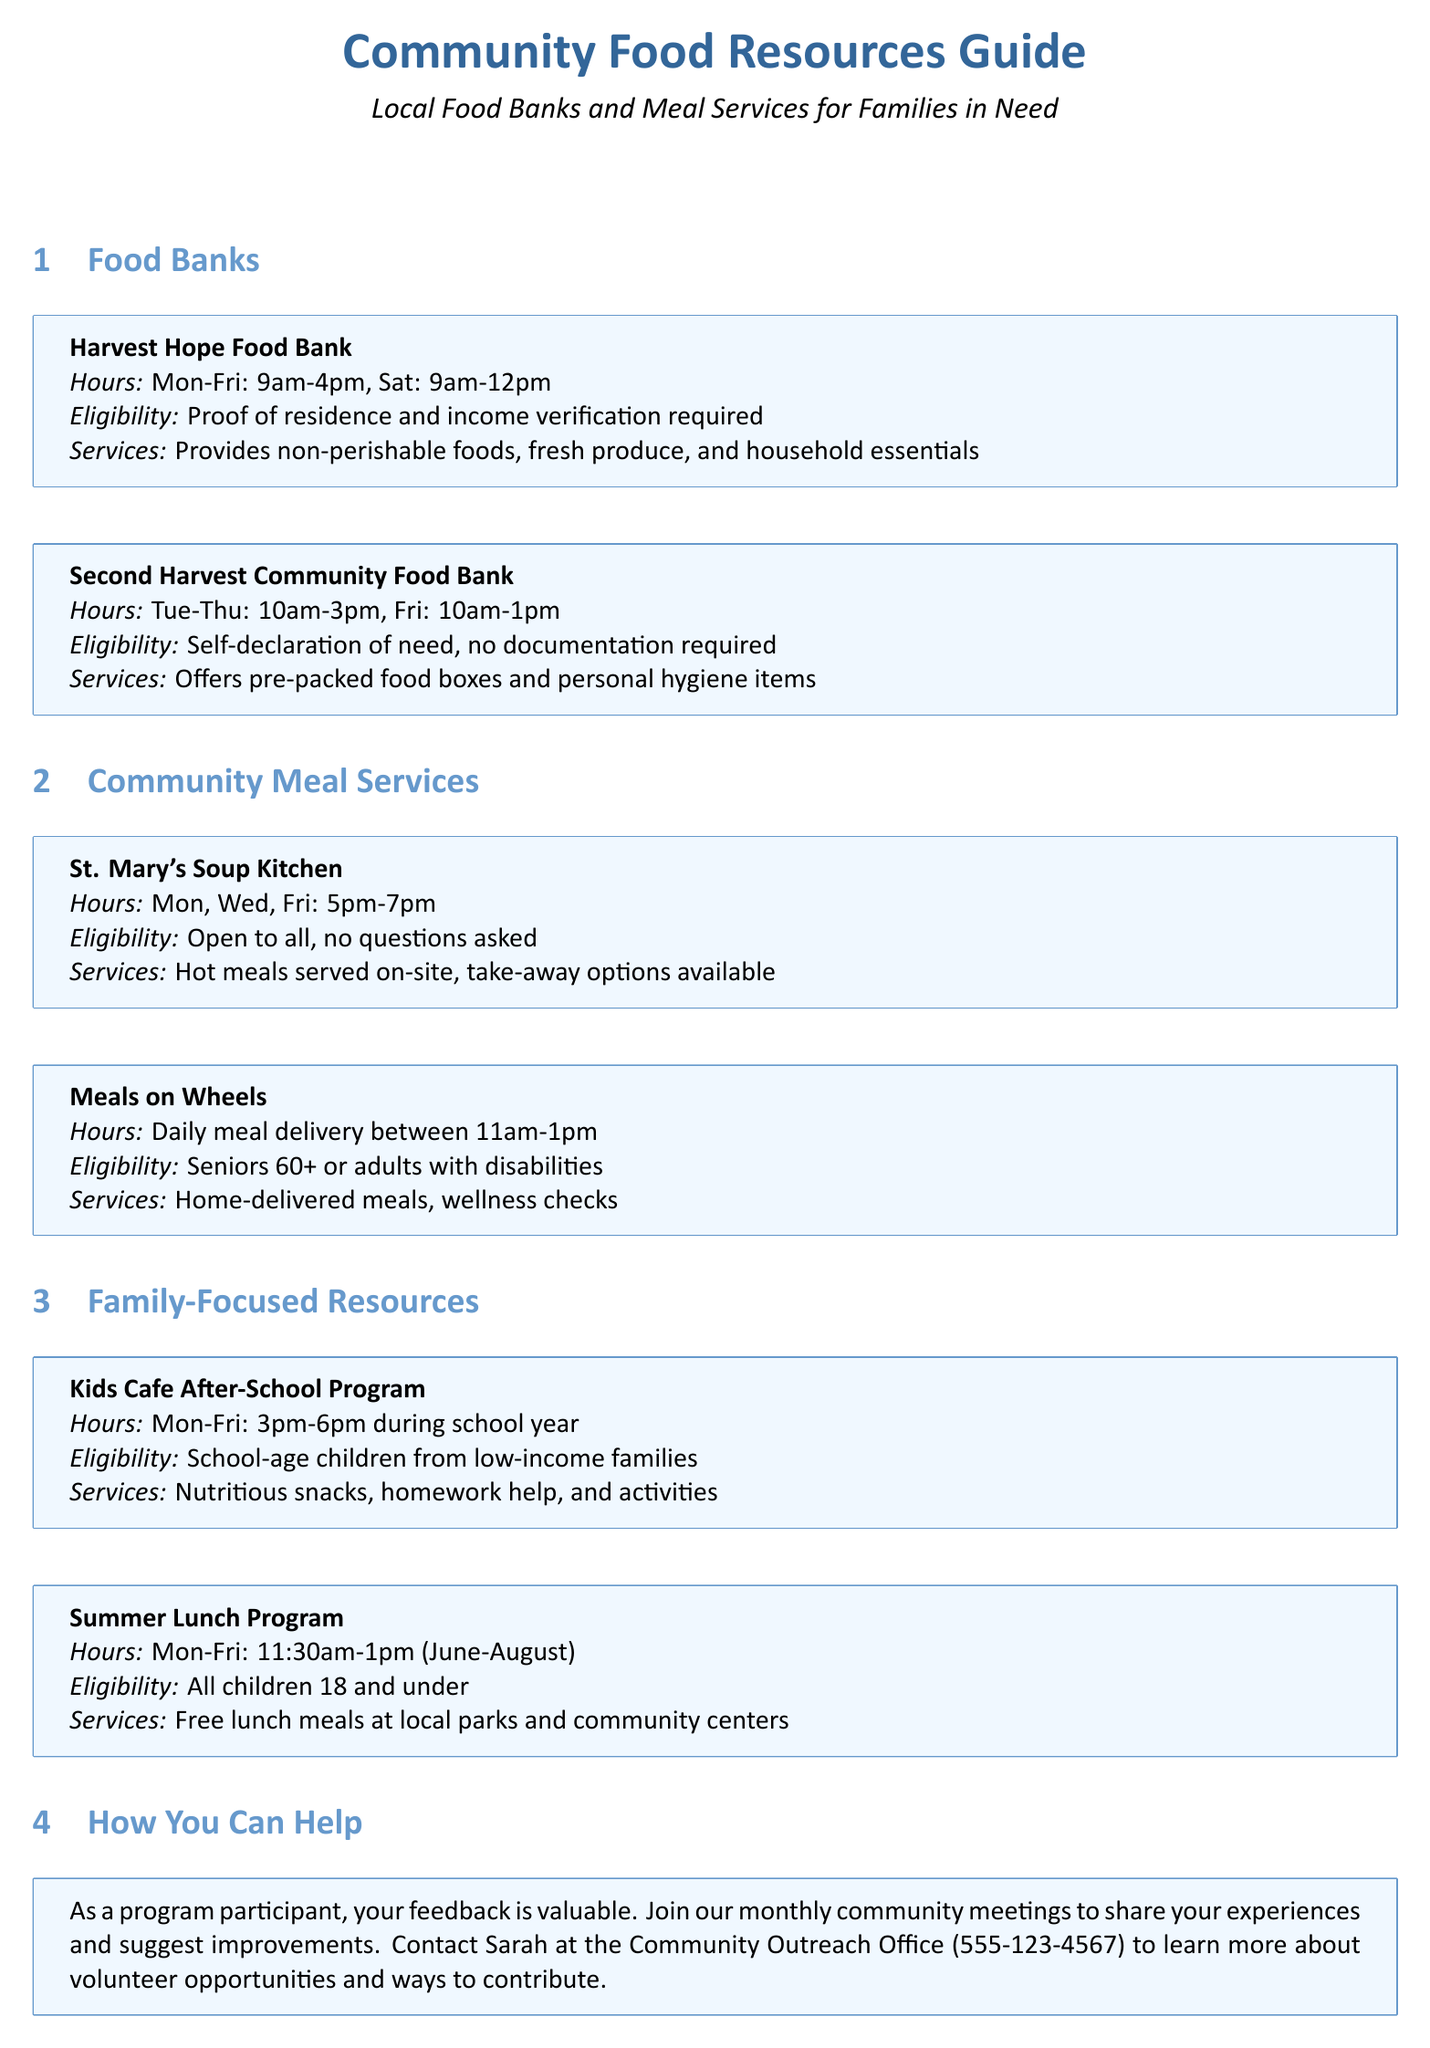What are the operating hours of Harvest Hope Food Bank? The operating hours can be found in the resource box for Harvest Hope Food Bank, which specifies the days and times it is open.
Answer: Mon-Fri: 9am-4pm, Sat: 9am-12pm What is required for eligibility at Second Harvest Community Food Bank? The eligibility requirements for Second Harvest Community Food Bank are detailed in the resource box, indicating what documentation is needed for access.
Answer: Self-declaration of need, no documentation required What services are offered by St. Mary's Soup Kitchen? The services provided by St. Mary's Soup Kitchen are listed in its resource box, which outlines what to expect from the service.
Answer: Hot meals served on-site, take-away options available Which program offers free lunch during the summer? The Summer Lunch Program specifies in the document that it offers meals during a certain time period, indicating it is aimed at children.
Answer: Summer Lunch Program How often does Meals on Wheels deliver meals? The frequency of the delivery by Meals on Wheels can be determined by looking at the food services section of the document where it describes the service details.
Answer: Daily What ages are eligible for the Kids Cafe After-School Program? The eligibility age for the Kids Cafe After-School Program is included in the resource box, detailing the target demographic for this service.
Answer: School-age children from low-income families What is the contact number to learn about volunteer opportunities? The document provides a specific contact number for those interested in volunteering and contributing to community outreach efforts.
Answer: 555-123-4567 In what months does the Summer Lunch Program operate? The operational months for the Summer Lunch Program are indicated in the relevant resource box, outlining its seasonal availability.
Answer: June-August 